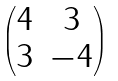<formula> <loc_0><loc_0><loc_500><loc_500>\begin{pmatrix} 4 & 3 \\ 3 & - 4 \end{pmatrix}</formula> 